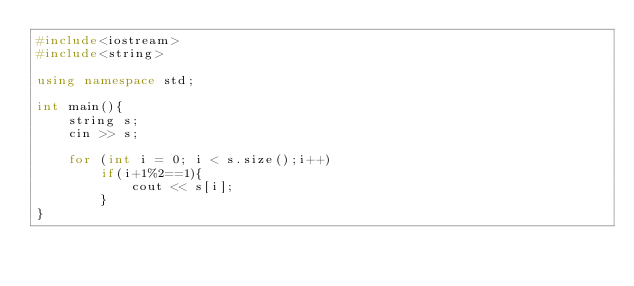<code> <loc_0><loc_0><loc_500><loc_500><_C++_>#include<iostream>
#include<string>

using namespace std;

int main(){
    string s;
    cin >> s;

    for (int i = 0; i < s.size();i++)
        if(i+1%2==1){
            cout << s[i];
        }
}</code> 